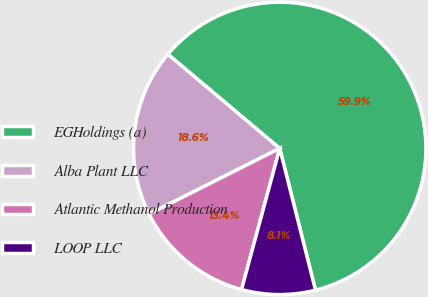Convert chart. <chart><loc_0><loc_0><loc_500><loc_500><pie_chart><fcel>EGHoldings (a)<fcel>Alba Plant LLC<fcel>Atlantic Methanol Production<fcel>LOOP LLC<nl><fcel>59.93%<fcel>18.55%<fcel>13.38%<fcel>8.14%<nl></chart> 